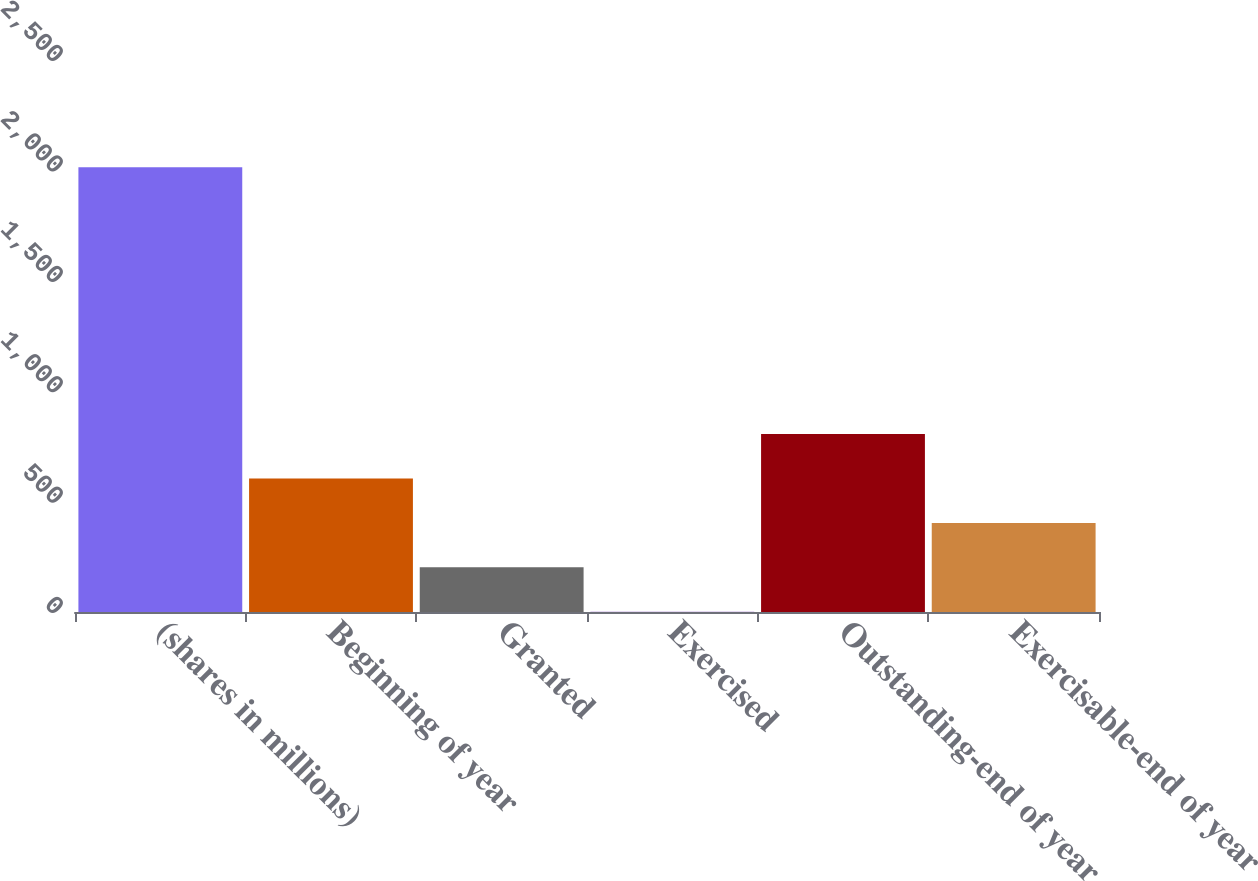<chart> <loc_0><loc_0><loc_500><loc_500><bar_chart><fcel>(shares in millions)<fcel>Beginning of year<fcel>Granted<fcel>Exercised<fcel>Outstanding-end of year<fcel>Exercisable-end of year<nl><fcel>2014<fcel>604.76<fcel>202.12<fcel>0.8<fcel>806.08<fcel>403.44<nl></chart> 